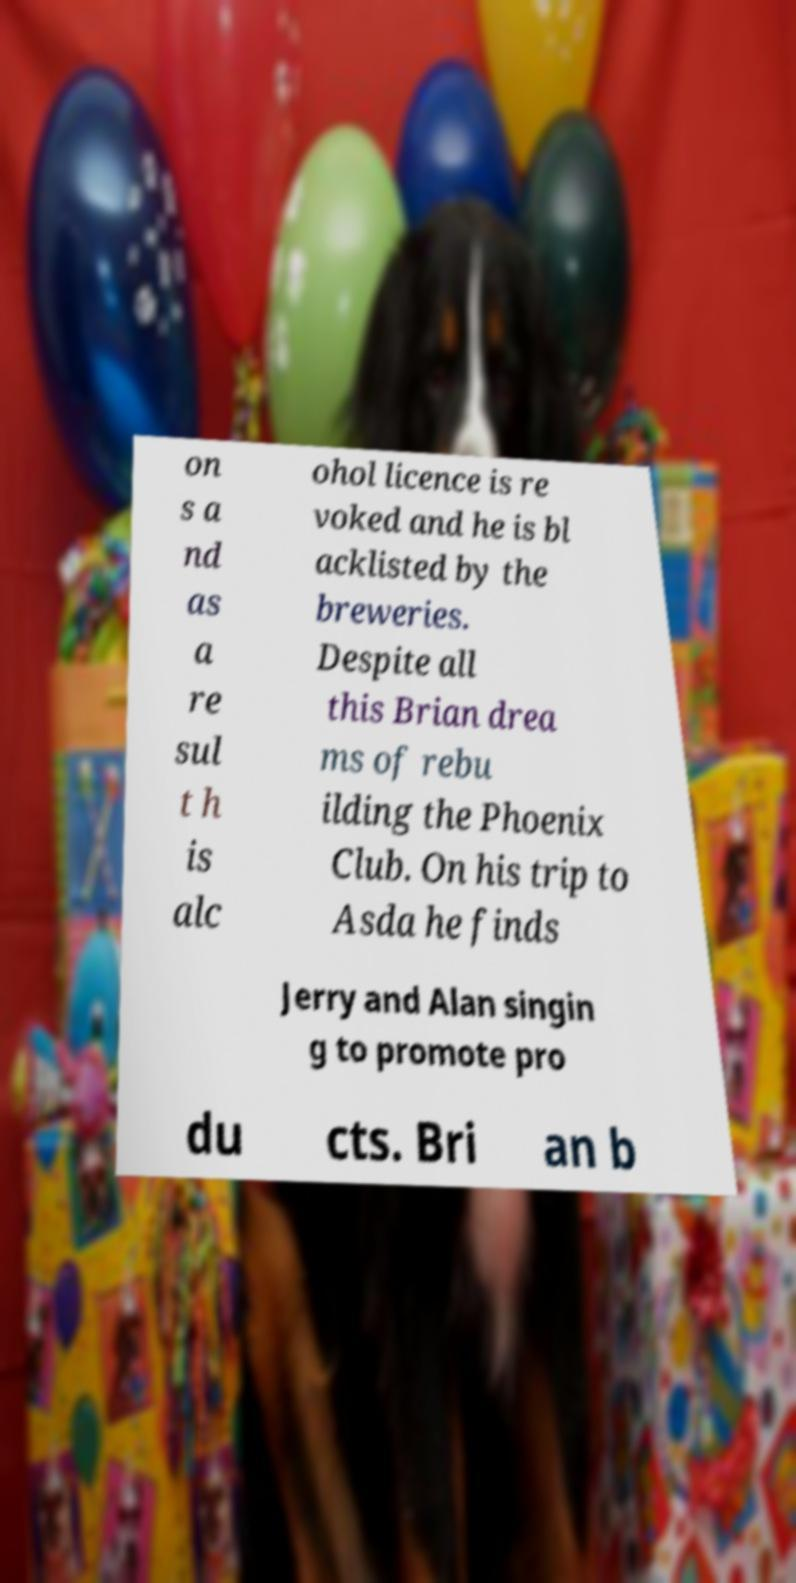Please identify and transcribe the text found in this image. on s a nd as a re sul t h is alc ohol licence is re voked and he is bl acklisted by the breweries. Despite all this Brian drea ms of rebu ilding the Phoenix Club. On his trip to Asda he finds Jerry and Alan singin g to promote pro du cts. Bri an b 